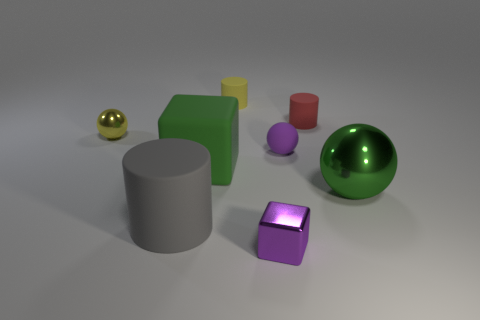Add 2 blue shiny balls. How many objects exist? 10 Subtract all large gray rubber cylinders. How many cylinders are left? 2 Subtract all purple blocks. How many blocks are left? 1 Subtract 1 cubes. How many cubes are left? 1 Subtract all balls. How many objects are left? 5 Subtract all blue cubes. Subtract all cyan cylinders. How many cubes are left? 2 Subtract all yellow cubes. How many cyan cylinders are left? 0 Subtract all tiny shiny cylinders. Subtract all balls. How many objects are left? 5 Add 3 purple blocks. How many purple blocks are left? 4 Add 1 rubber objects. How many rubber objects exist? 6 